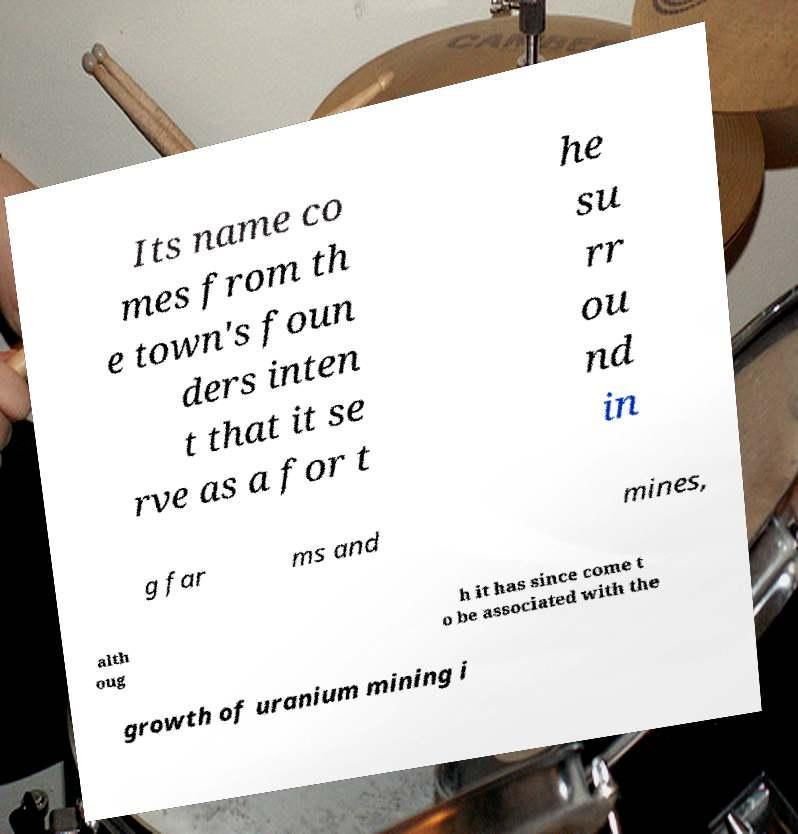Could you extract and type out the text from this image? Its name co mes from th e town's foun ders inten t that it se rve as a for t he su rr ou nd in g far ms and mines, alth oug h it has since come t o be associated with the growth of uranium mining i 